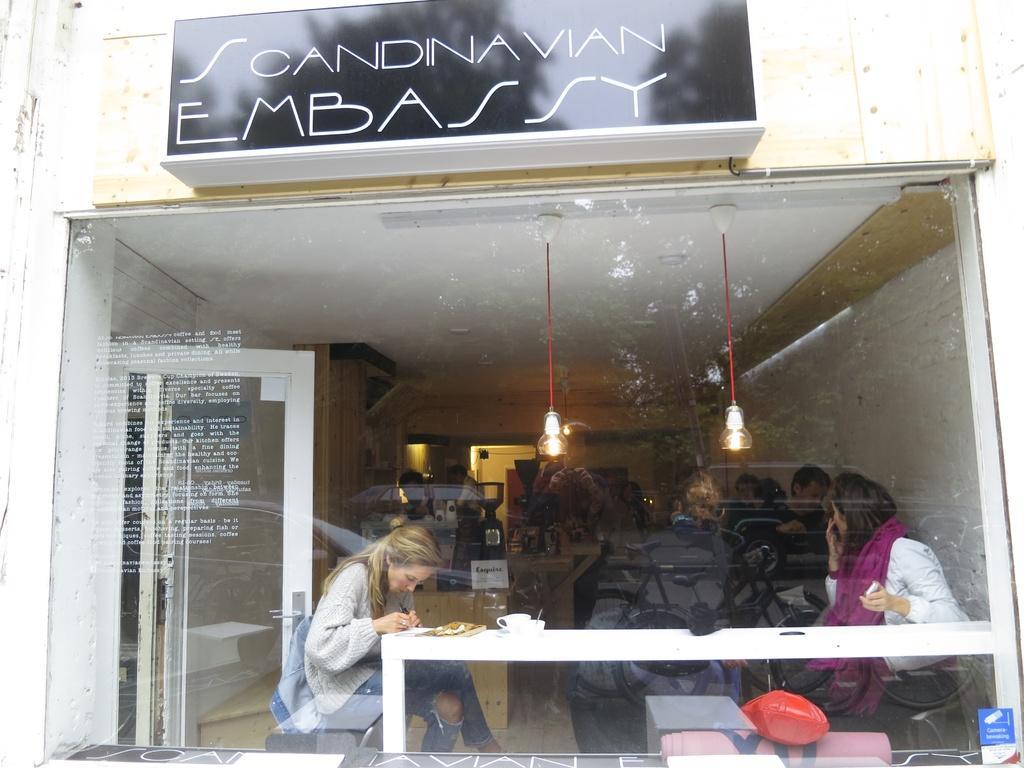Describe this image in one or two sentences. Through this glass window we can see people, lights and table. On this table there is a food and objects. These two people are sitting on chairs and holding objects. On this wall there is a board. 